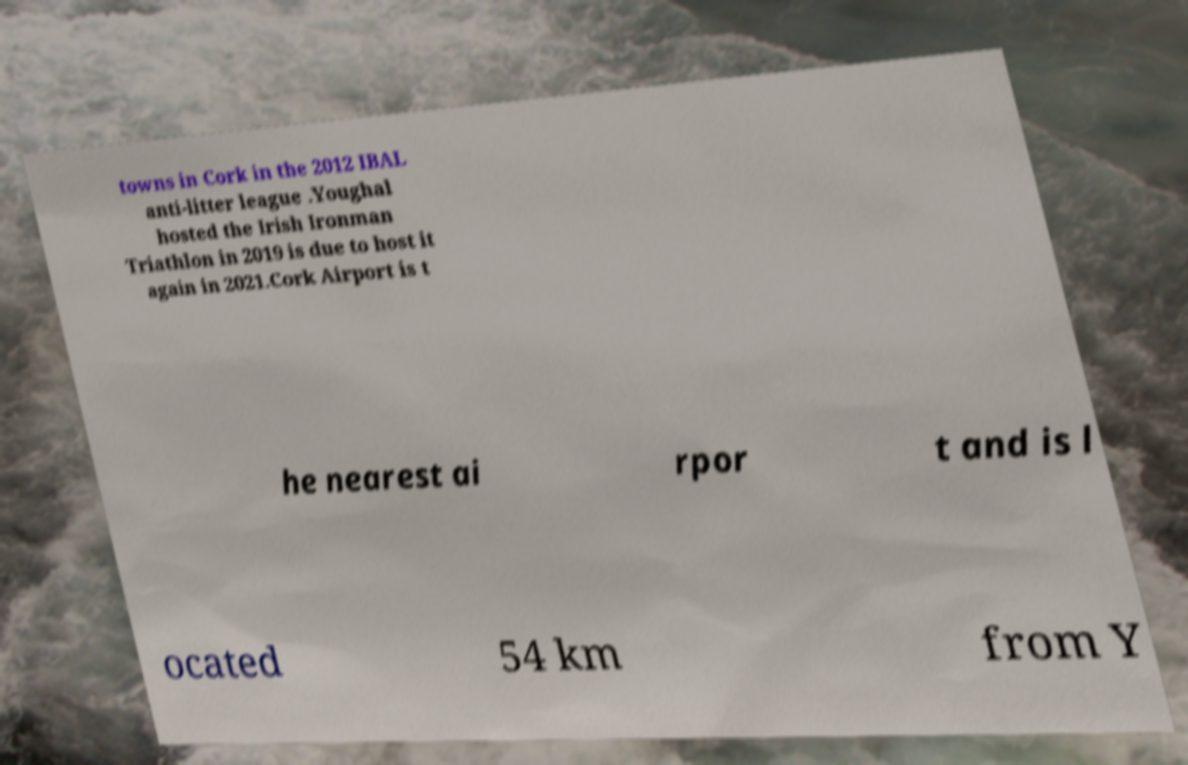Can you accurately transcribe the text from the provided image for me? towns in Cork in the 2012 IBAL anti-litter league .Youghal hosted the Irish Ironman Triathlon in 2019 is due to host it again in 2021.Cork Airport is t he nearest ai rpor t and is l ocated 54 km from Y 